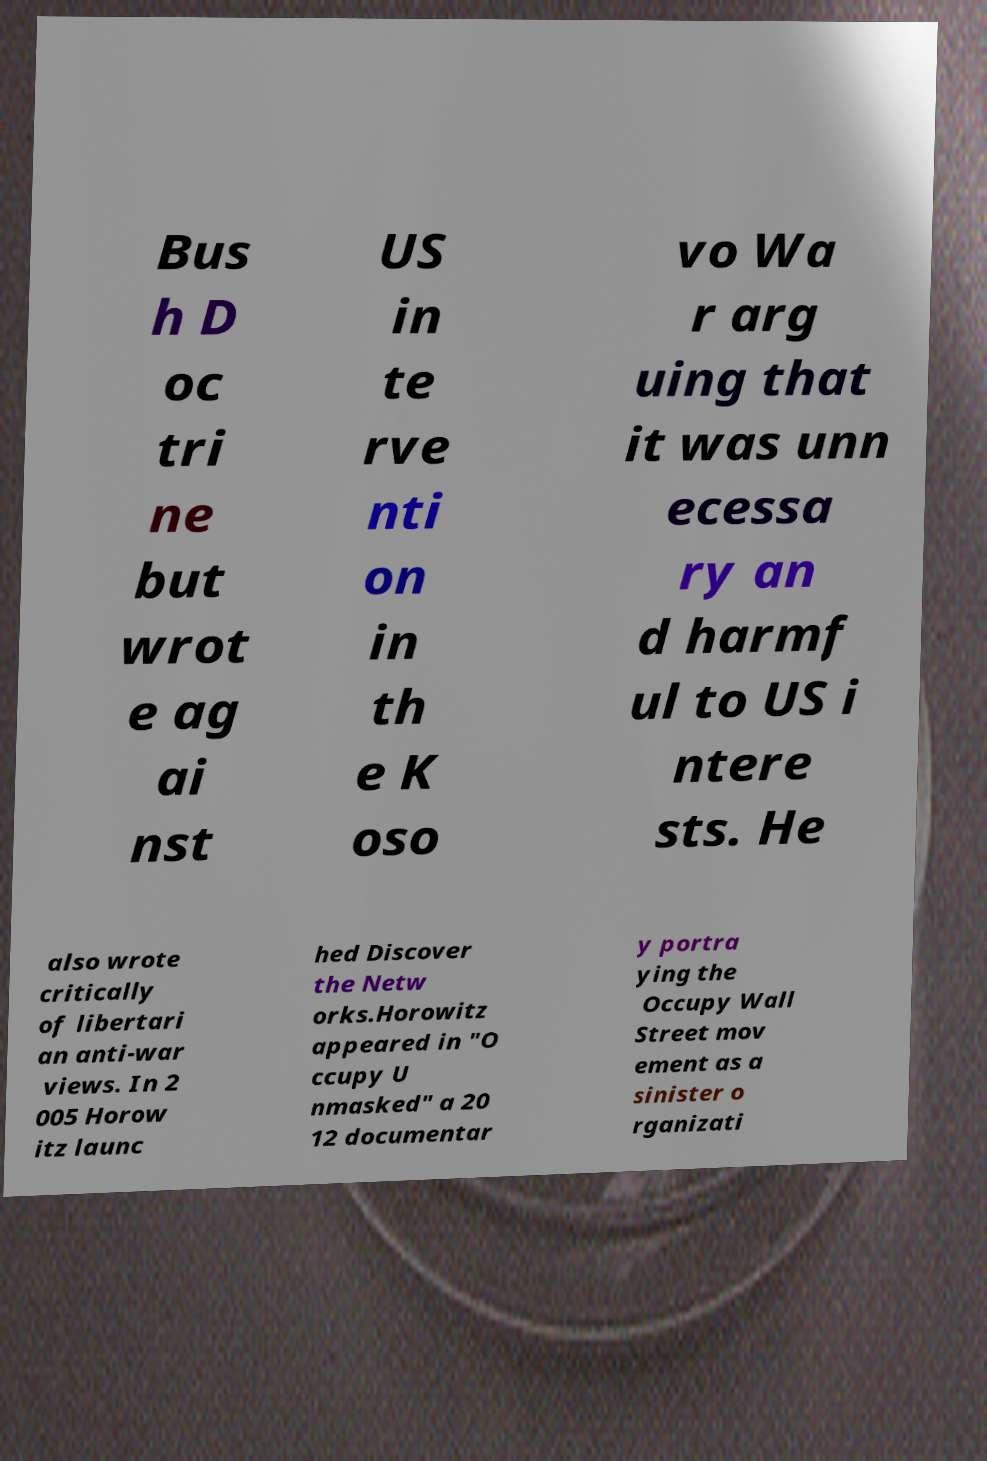Could you extract and type out the text from this image? Bus h D oc tri ne but wrot e ag ai nst US in te rve nti on in th e K oso vo Wa r arg uing that it was unn ecessa ry an d harmf ul to US i ntere sts. He also wrote critically of libertari an anti-war views. In 2 005 Horow itz launc hed Discover the Netw orks.Horowitz appeared in "O ccupy U nmasked" a 20 12 documentar y portra ying the Occupy Wall Street mov ement as a sinister o rganizati 